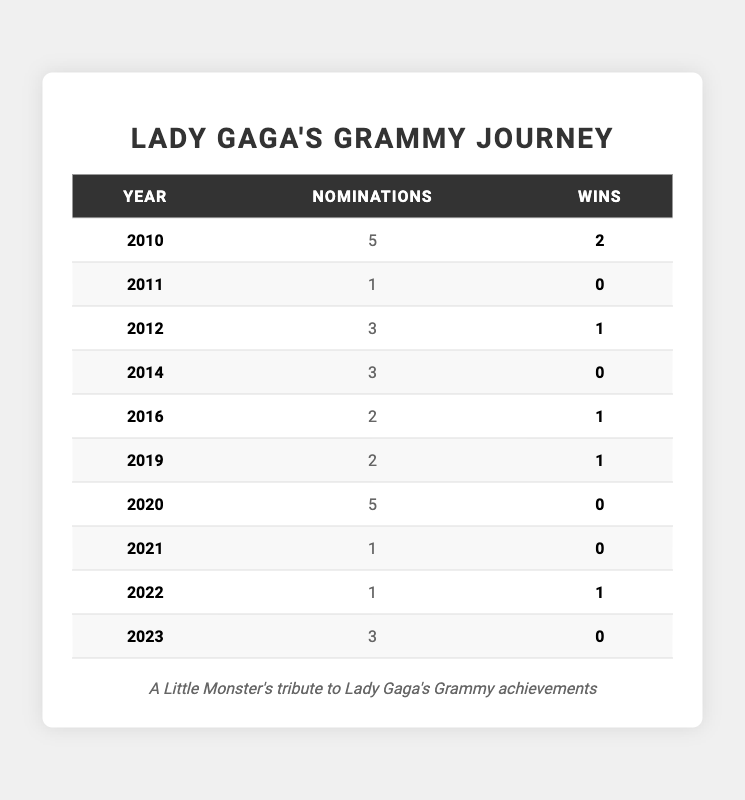What year did Lady Gaga receive the most Grammy nominations? In 2010, Lady Gaga had 5 nominations, which is the highest number of nominations recorded in the table.
Answer: 2010 How many total Grammy wins does Lady Gaga have up to 2023? By adding the wins from each year: 2 (2010) + 0 (2011) + 1 (2012) + 0 (2014) + 1 (2016) + 1 (2019) + 0 (2020) + 0 (2021) + 1 (2022) + 0 (2023) = 6 wins total.
Answer: 6 Did Lady Gaga win a Grammy in 2011? According to the data, Lady Gaga had 1 nomination in 2011 but did not secure any wins.
Answer: No What is the average number of nominations Lady Gaga received per year from 2010 to 2023? To calculate the average, add total nominations: 5 + 1 + 3 + 3 + 2 + 2 + 5 + 1 + 1 + 3 = 22 nominations over 10 years, so the average is 22/10 = 2.2.
Answer: 2.2 Which years did Lady Gaga not win any Grammy awards? The years with no wins are 2011, 2014, 2020, and 2021, as shown in the table.
Answer: 2011, 2014, 2020, 2021 How many more nominations did she receive in 2010 compared to 2021? In 2010, she had 5 nominations, and in 2021 she had 1 nomination. The difference is 5 - 1 = 4.
Answer: 4 In which years did Lady Gaga have more wins than nominations? She had more wins than nominations in 2012 and 2022, with 1 win each while having 3 and 1 nominations respectively.
Answer: 2012, 2022 What is the total number of nominations from the years she won at least one Grammy? She won Grammys in 2010 (5 nominations), 2012 (3 nominations), 2016 (2 nominations), 2019 (2 nominations), and 2022 (1 nomination). Adding these gives 5 + 3 + 2 + 2 + 1 = 13 nominations.
Answer: 13 What percentage of her total Grammy nominations resulted in wins? Total nominations are 22 and total wins are 6, so the percentage is calculated as (6/22) * 100 = 27.27% (rounded to two decimal places).
Answer: 27.27% How many years did Lady Gaga have Grammy nominations but no wins? She had no wins in 2011, 2014, 2020, and 2021, totaling 4 years without wins despite having nominations.
Answer: 4 